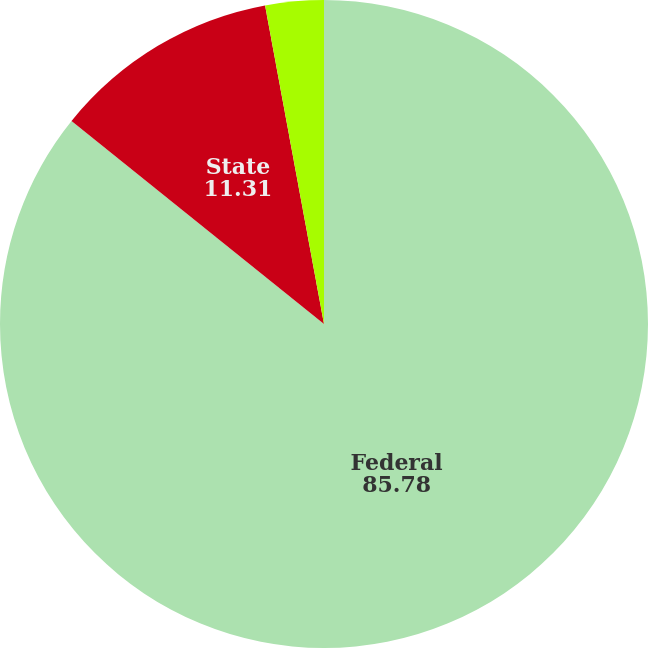<chart> <loc_0><loc_0><loc_500><loc_500><pie_chart><fcel>Federal<fcel>State<fcel>Foreign<nl><fcel>85.78%<fcel>11.31%<fcel>2.91%<nl></chart> 